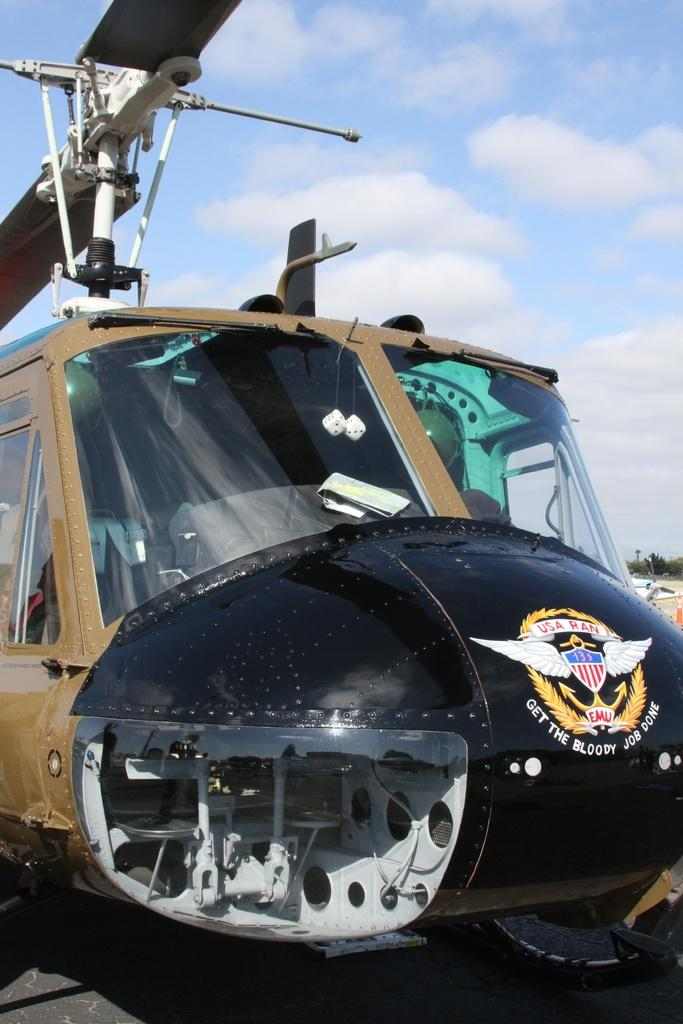What is the main subject of the image? The main subject of the image is a vehicle. What distinguishing feature does the vehicle have? The vehicle has wings on top. How many wounds can be seen on the vehicle in the image? There are no wounds visible on the vehicle in the image. What season is depicted in the image? The provided facts do not mention any season or weather-related details, so it cannot be determined from the image. 